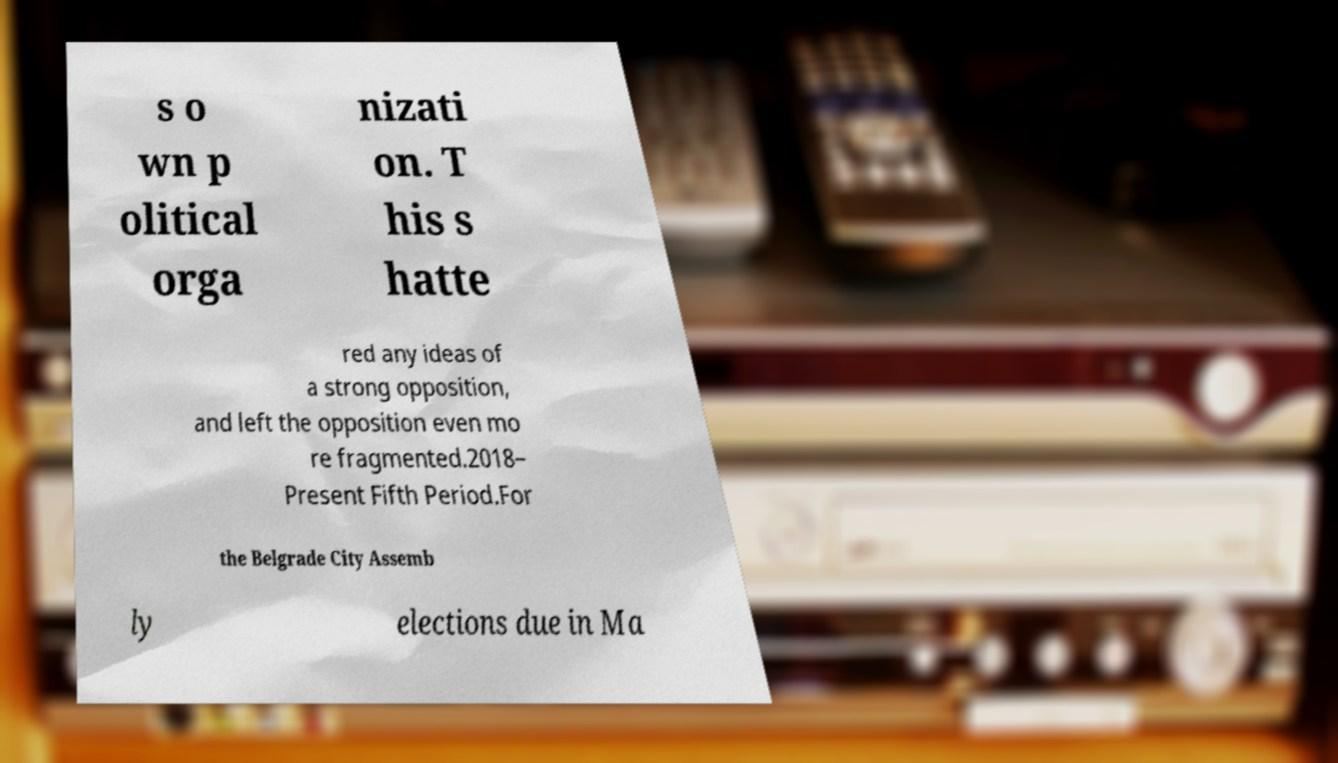I need the written content from this picture converted into text. Can you do that? s o wn p olitical orga nizati on. T his s hatte red any ideas of a strong opposition, and left the opposition even mo re fragmented.2018– Present Fifth Period.For the Belgrade City Assemb ly elections due in Ma 